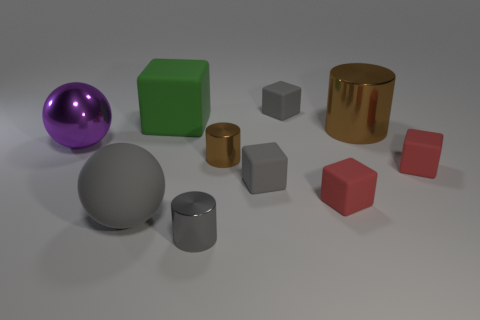Subtract all green matte cubes. How many cubes are left? 4 Subtract all green blocks. How many blocks are left? 4 Subtract 3 blocks. How many blocks are left? 2 Subtract all green cubes. Subtract all cyan cylinders. How many cubes are left? 4 Subtract all cylinders. How many objects are left? 7 Subtract all purple rubber cylinders. Subtract all small red things. How many objects are left? 8 Add 3 blocks. How many blocks are left? 8 Add 9 large blue blocks. How many large blue blocks exist? 9 Subtract 1 green blocks. How many objects are left? 9 